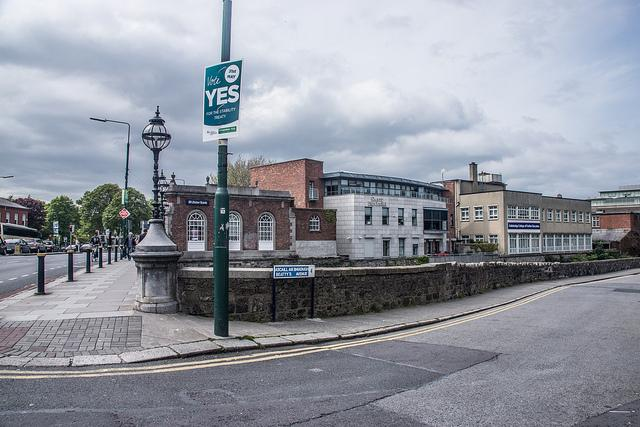The clouds here indicate what might happen? rain 